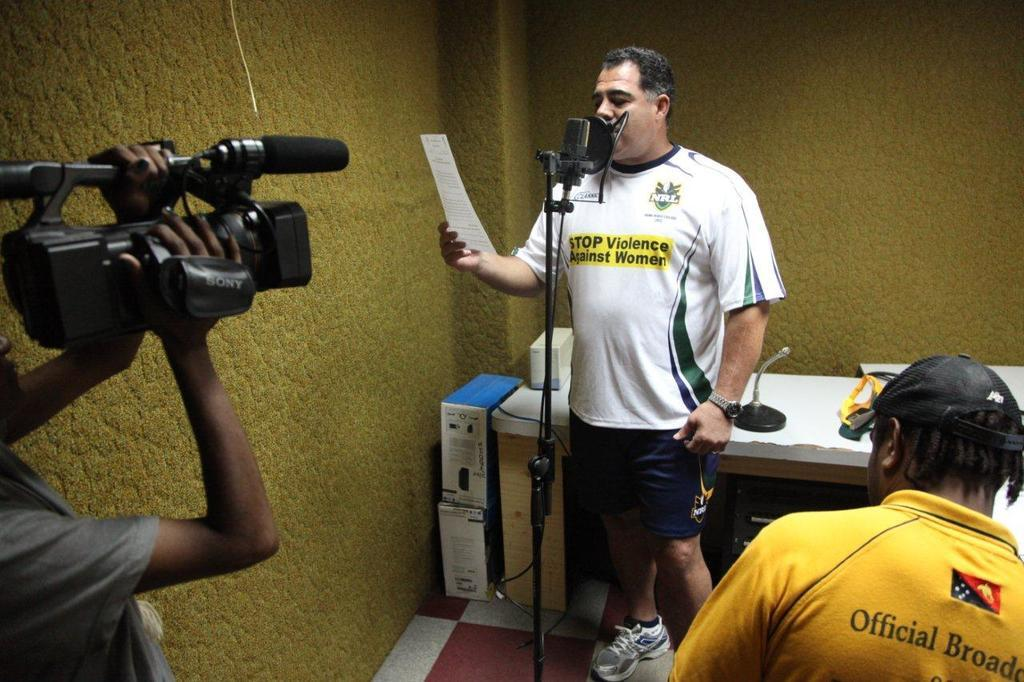<image>
Give a short and clear explanation of the subsequent image. A recording of a message to promote nonviolence against women 